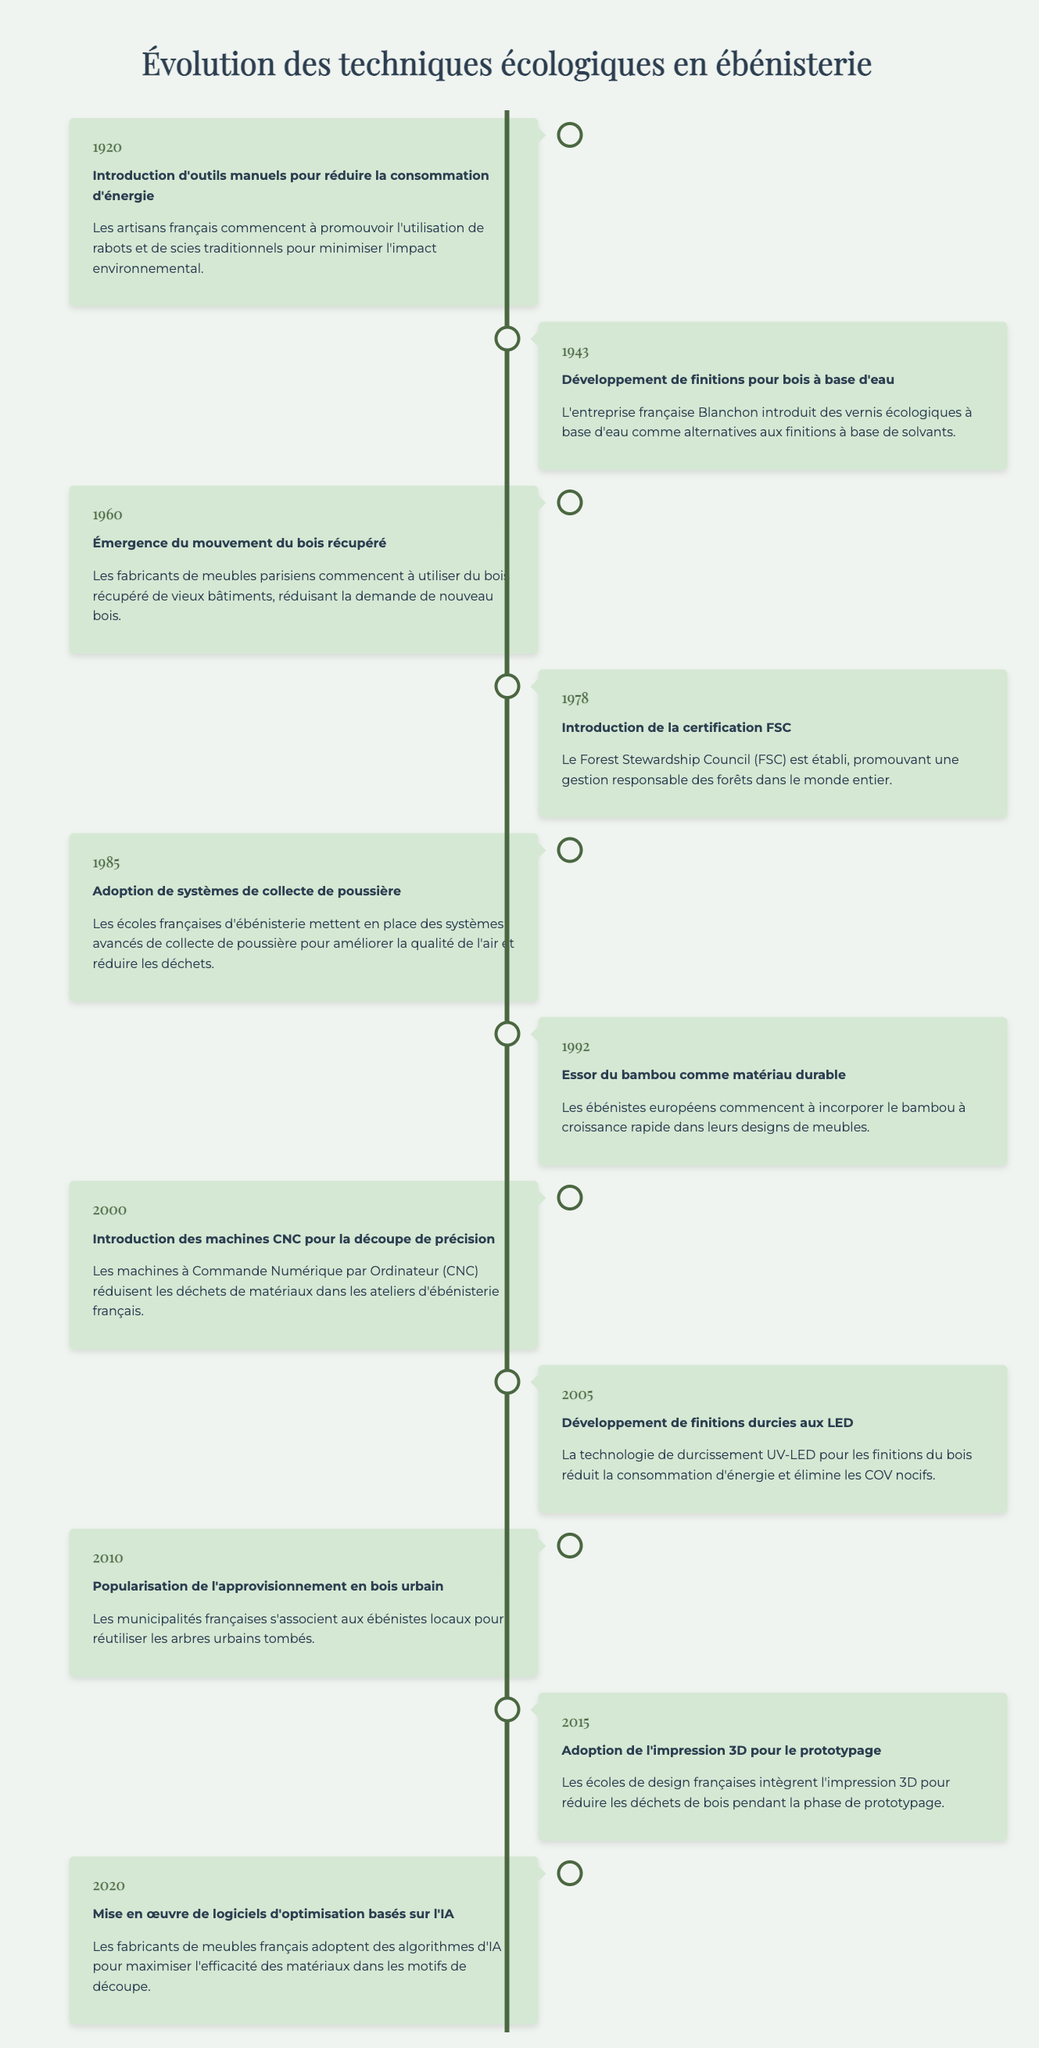What event marked the beginning of eco-friendly woodworking techniques in 1920? According to the timeline, the event in 1920 is the introduction of hand-powered tools for reduced energy consumption. This indicates that craftsmen in France began promoting the use of traditional hand planes and saws to minimize environmental impact.
Answer: Introduction of hand-powered tools for reduced energy consumption What year did the Forest Stewardship Council (FSC) get established? The timeline explicitly states that FSC was established in 1978 to promote responsible forest management worldwide.
Answer: 1978 Is it true that bamboo became recognized as a sustainable material in 1992? By checking the timeline, in the year 1992, it indicates that bamboo started to be recognized as a sustainable material by European woodworkers. Therefore, the statement is true.
Answer: Yes What would be the chronological order of the first three events listed in the timeline? The first three events listed are: 1) 1920 - Introduction of hand-powered tools, 2) 1943 - Development of water-based wood finishes, and 3) 1960 - Emergence of reclaimed wood movement. Thus, the chronological order is 1920, 1943, 1960.
Answer: 1920, 1943, 1960 How many events from 2000 or later focus on the use of technology? The events listed from 2000 or later are: 2000 - CNC machines for precision cutting, 2005 - LED-cured finishes, 2010 - urban wood sourcing, 2015 - 3D printing for prototyping, and 2020 - AI-powered optimization software. This totals to five events that focus on the use of technology.
Answer: 5 